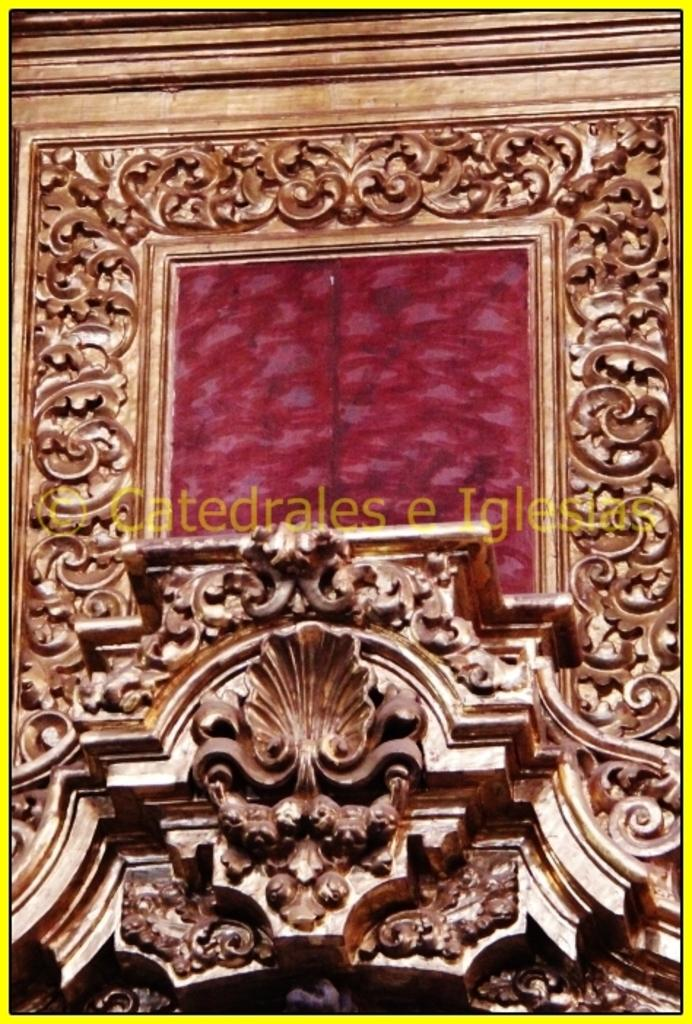<image>
Present a compact description of the photo's key features. A gold leaf design frame with a red framed center of a Catedrales e Iglesia 